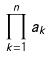<formula> <loc_0><loc_0><loc_500><loc_500>\prod _ { k = 1 } ^ { n } a _ { k }</formula> 